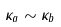Convert formula to latex. <formula><loc_0><loc_0><loc_500><loc_500>\kappa _ { a } \sim \kappa _ { b }</formula> 